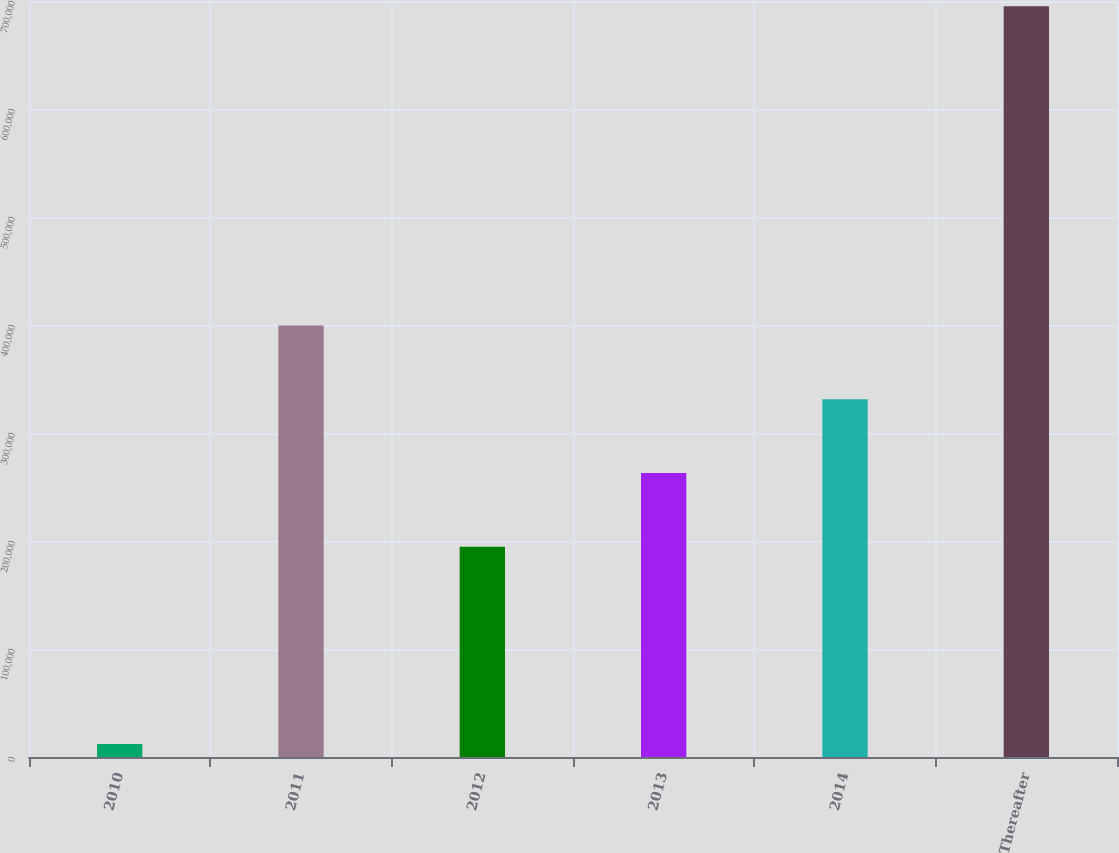Convert chart. <chart><loc_0><loc_0><loc_500><loc_500><bar_chart><fcel>2010<fcel>2011<fcel>2012<fcel>2013<fcel>2014<fcel>Thereafter<nl><fcel>12036<fcel>399522<fcel>194607<fcel>262912<fcel>331217<fcel>695087<nl></chart> 